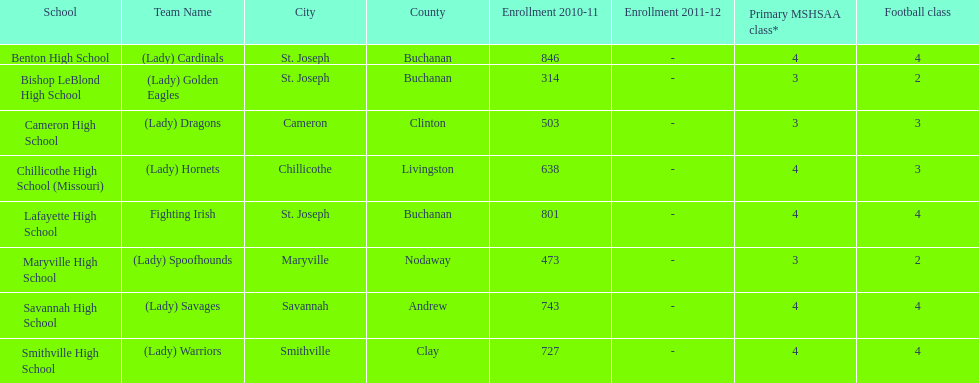What school has 3 football classes but only has 638 student enrollment? Chillicothe High School (Missouri). 